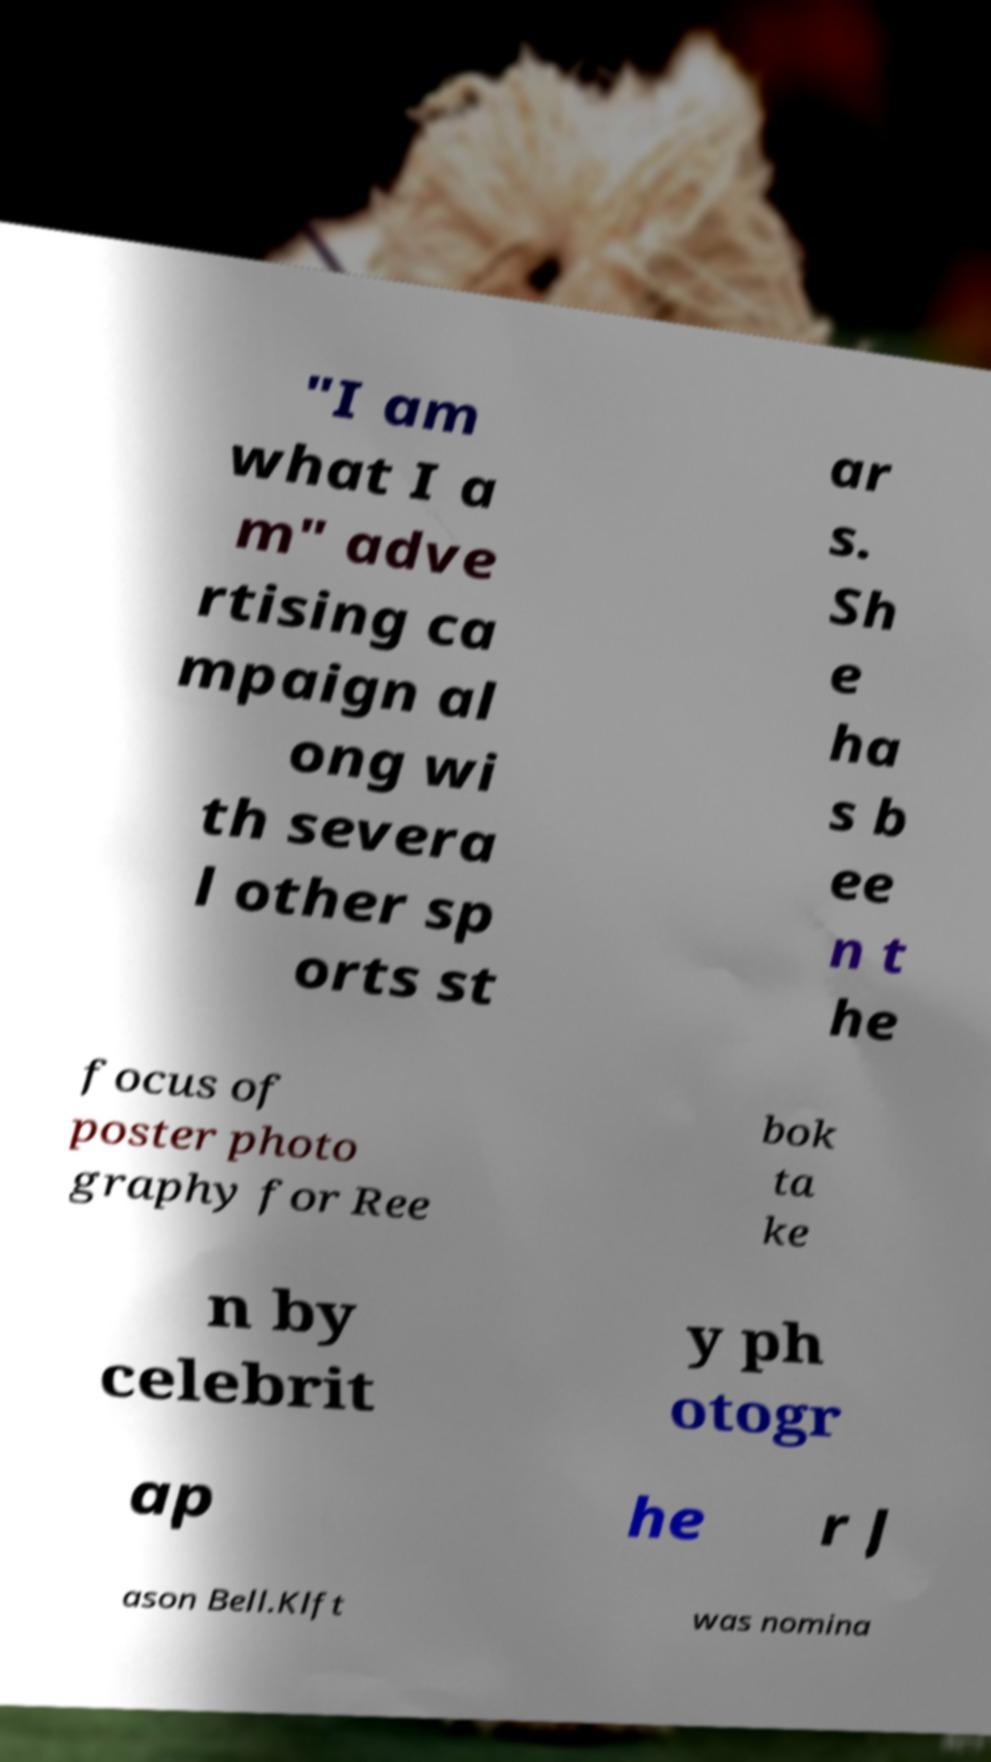Please identify and transcribe the text found in this image. "I am what I a m" adve rtising ca mpaign al ong wi th severa l other sp orts st ar s. Sh e ha s b ee n t he focus of poster photo graphy for Ree bok ta ke n by celebrit y ph otogr ap he r J ason Bell.Klft was nomina 